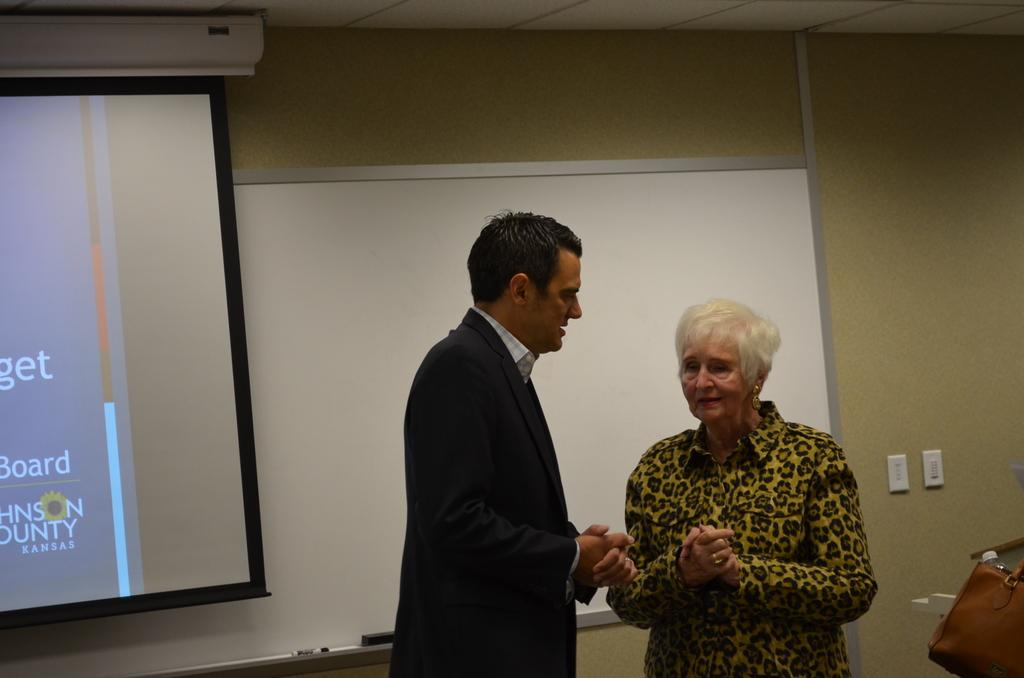How many people are present in the image? There are two people, a man and a woman, present in the image. What is located in the background of the image? There is a white color board and switches on a wall in the background of the image. What is the primary object in the image? There is a projector screen in the image. What type of curtain is hanging in front of the projector screen in the image? There is no curtain present in the image; the projector screen is visible without any obstructions. Can you tell me how many stamps are on the man's shirt in the image? There are no stamps visible on the man's shirt in the image. 